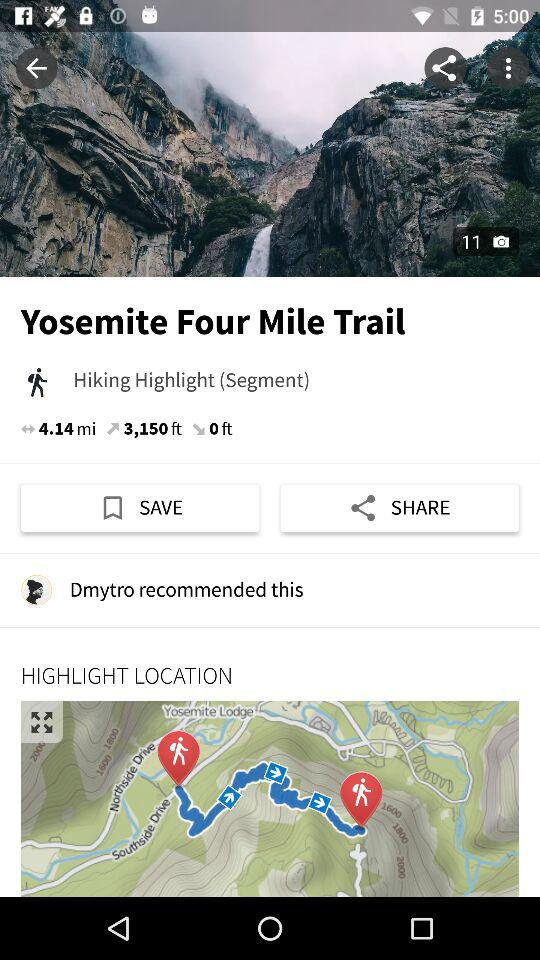What segment is it? The segment is Hiking Highlight. 